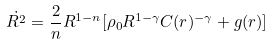<formula> <loc_0><loc_0><loc_500><loc_500>\dot { R ^ { 2 } } = \frac { 2 } { n } R ^ { 1 - n } [ \rho _ { 0 } R ^ { 1 - \gamma } C ( r ) ^ { - \gamma } + g ( r ) ]</formula> 